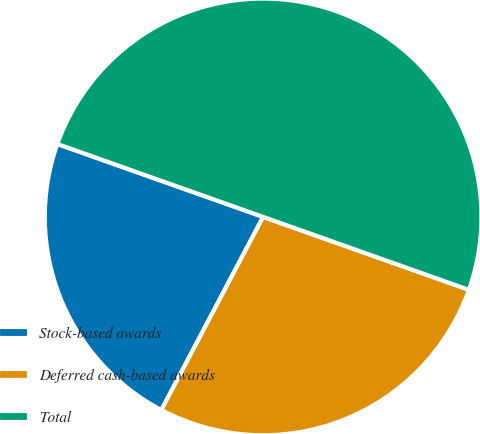Convert chart. <chart><loc_0><loc_0><loc_500><loc_500><pie_chart><fcel>Stock-based awards<fcel>Deferred cash-based awards<fcel>Total<nl><fcel>22.7%<fcel>27.3%<fcel>50.0%<nl></chart> 